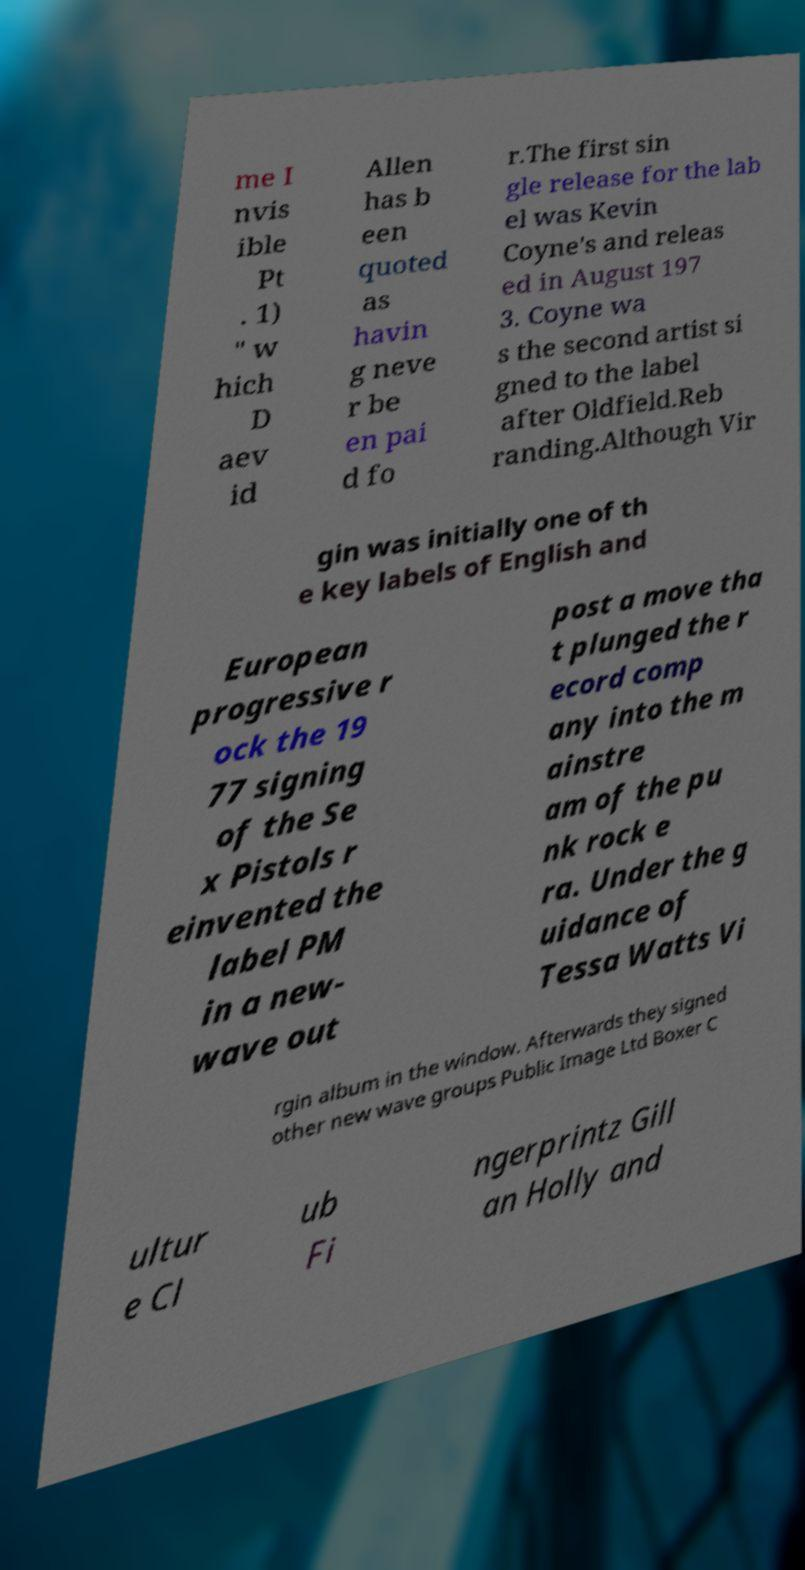Could you extract and type out the text from this image? me I nvis ible Pt . 1) " w hich D aev id Allen has b een quoted as havin g neve r be en pai d fo r.The first sin gle release for the lab el was Kevin Coyne's and releas ed in August 197 3. Coyne wa s the second artist si gned to the label after Oldfield.Reb randing.Although Vir gin was initially one of th e key labels of English and European progressive r ock the 19 77 signing of the Se x Pistols r einvented the label PM in a new- wave out post a move tha t plunged the r ecord comp any into the m ainstre am of the pu nk rock e ra. Under the g uidance of Tessa Watts Vi rgin album in the window. Afterwards they signed other new wave groups Public Image Ltd Boxer C ultur e Cl ub Fi ngerprintz Gill an Holly and 